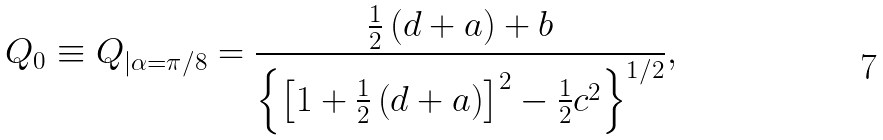<formula> <loc_0><loc_0><loc_500><loc_500>Q _ { 0 } \equiv Q _ { | \alpha = \pi / 8 } = \frac { \frac { 1 } { 2 } \left ( d + a \right ) + b } { \left \{ \left [ 1 + \frac { 1 } { 2 } \left ( d + a \right ) \right ] ^ { 2 } - \frac { 1 } { 2 } c ^ { 2 } \right \} ^ { 1 / 2 } } ,</formula> 